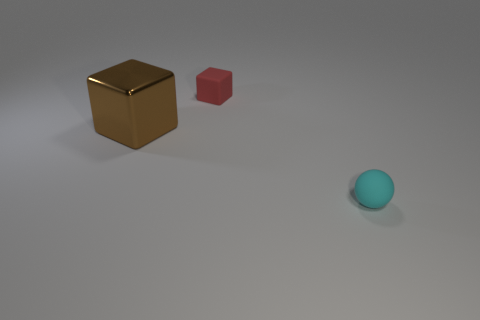Subtract all blocks. How many objects are left? 1 Subtract 1 cubes. How many cubes are left? 1 Subtract all brown blocks. Subtract all red spheres. How many blocks are left? 1 Subtract all red spheres. How many red cubes are left? 1 Subtract all brown things. Subtract all small cyan rubber balls. How many objects are left? 1 Add 2 rubber things. How many rubber things are left? 4 Add 2 large green cylinders. How many large green cylinders exist? 2 Add 2 large cubes. How many objects exist? 5 Subtract 0 green cubes. How many objects are left? 3 